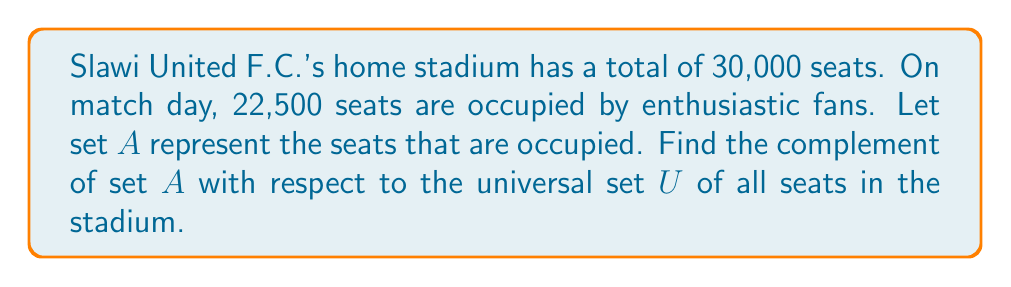Help me with this question. To solve this problem, we need to follow these steps:

1. Define the universal set $U$:
   $U$ = {all seats in the stadium} = 30,000 seats

2. Define set $A$:
   $A$ = {occupied seats} = 22,500 seats

3. Recall that the complement of a set $A$, denoted as $A^c$ or $\overline{A}$, is the set of all elements in the universal set $U$ that are not in $A$. 

4. To find the complement of $A$, we need to subtract the number of elements in $A$ from the total number of elements in $U$:

   $|A^c| = |U| - |A|$

   Where $|X|$ denotes the cardinality (number of elements) of set $X$.

5. Substitute the known values:
   $|A^c| = 30,000 - 22,500 = 7,500$

Therefore, the complement of set $A$ represents the number of available (unoccupied) seats in the stadium, which is 7,500.
Answer: $A^c = \{x \in U : x \notin A\}$, where $|A^c| = 7,500$ seats 